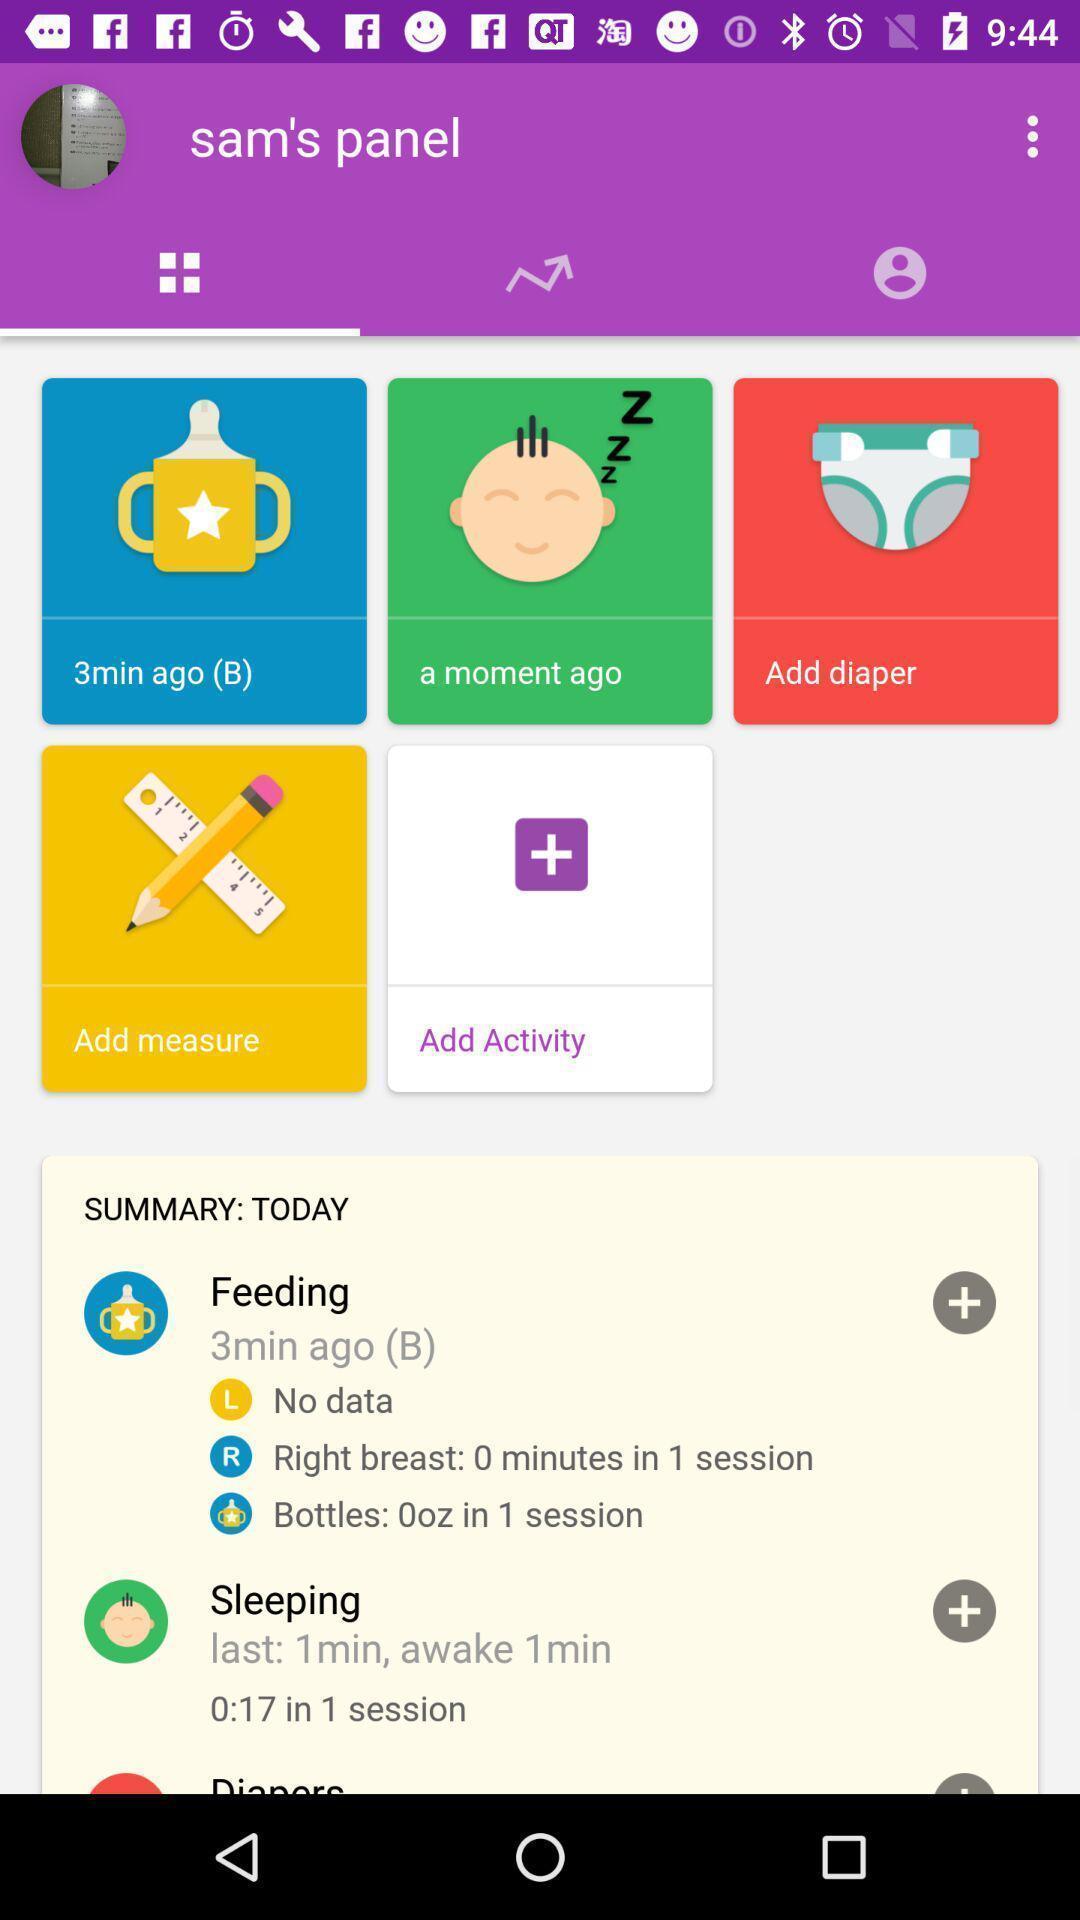Provide a textual representation of this image. Screen displaying the page of a baby app. 